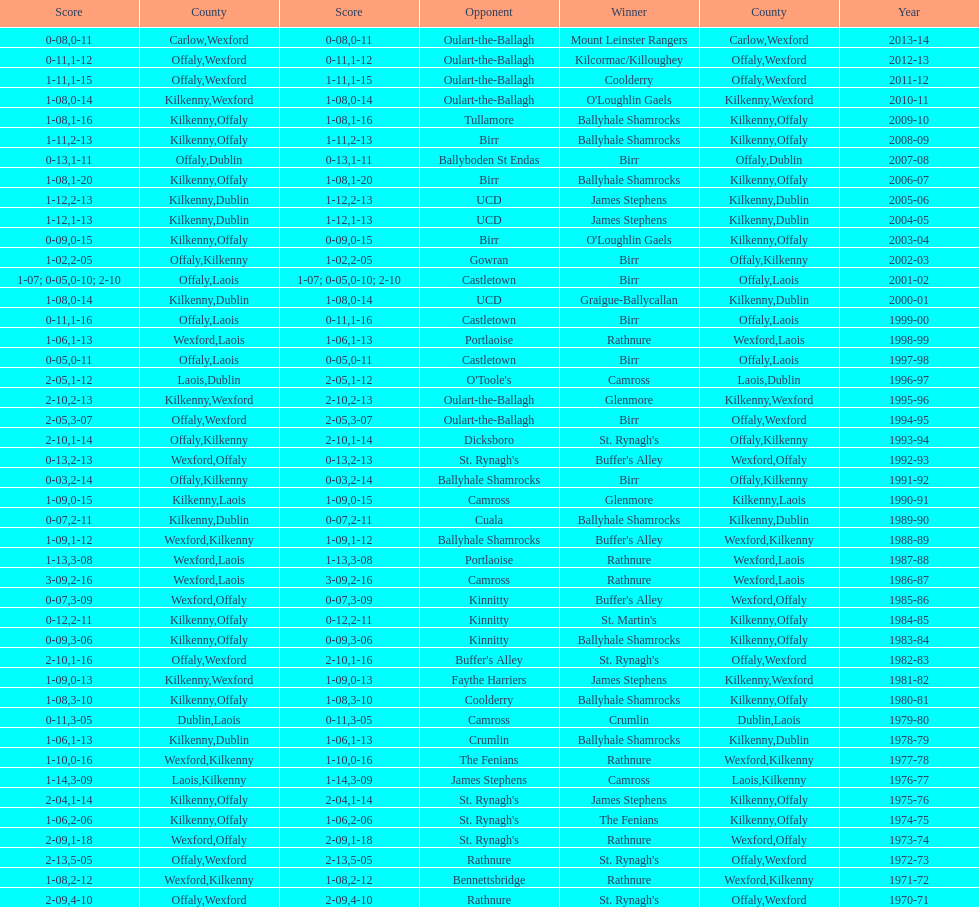Which victorious team is beside mount leinster rangers? Kilcormac/Killoughey. 